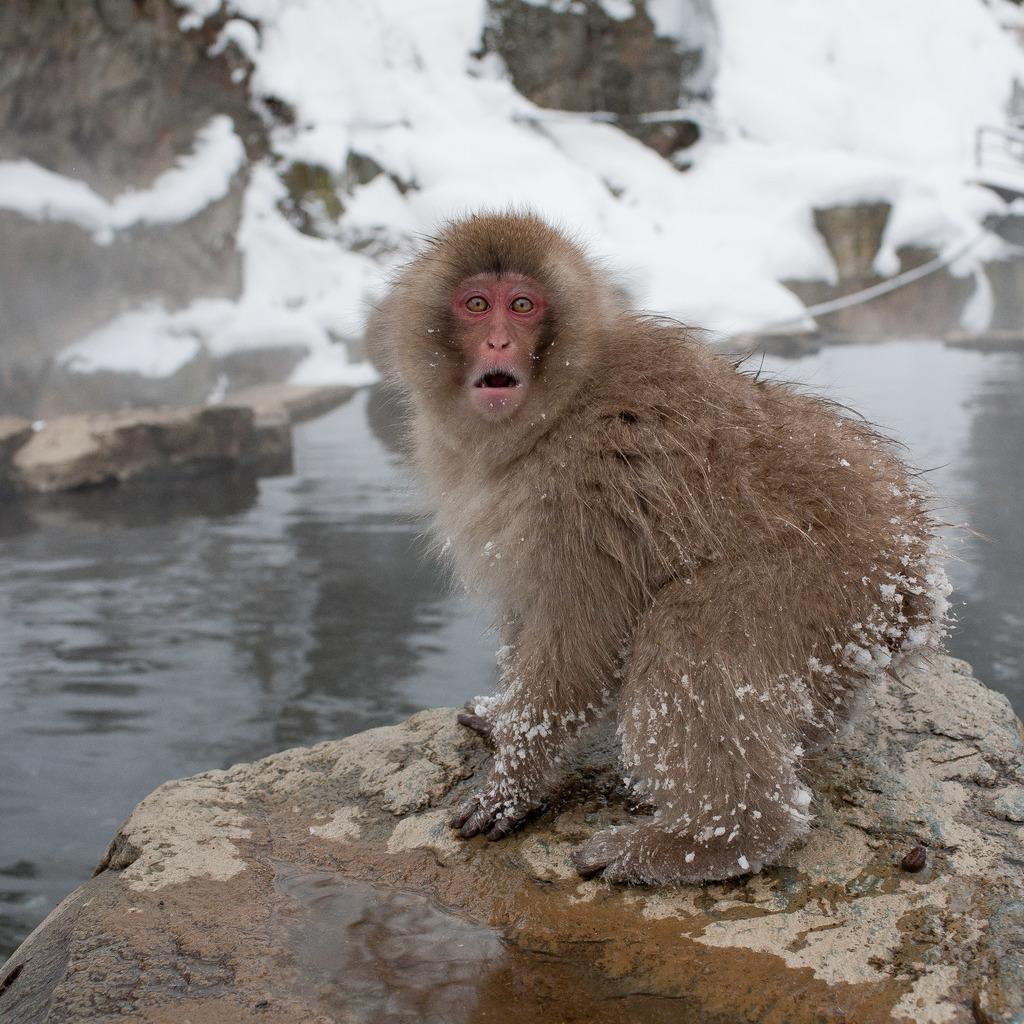How would you summarize this image in a sentence or two? In this image I can see a monkey looking at someone and in the middle there is a water. 